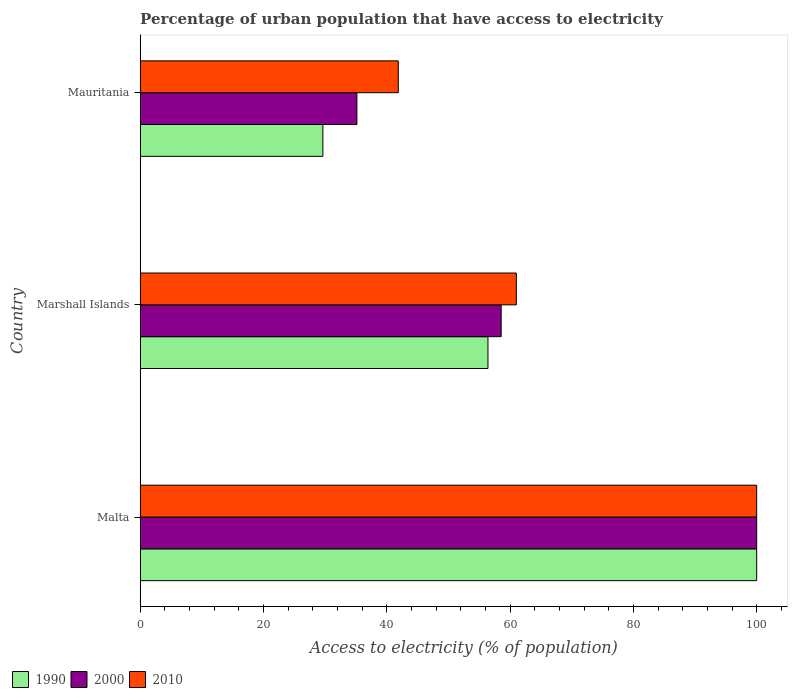How many different coloured bars are there?
Give a very brief answer. 3. Are the number of bars per tick equal to the number of legend labels?
Offer a terse response. Yes. How many bars are there on the 1st tick from the top?
Give a very brief answer. 3. How many bars are there on the 1st tick from the bottom?
Ensure brevity in your answer.  3. What is the label of the 3rd group of bars from the top?
Provide a succinct answer. Malta. In how many cases, is the number of bars for a given country not equal to the number of legend labels?
Your response must be concise. 0. What is the percentage of urban population that have access to electricity in 2000 in Mauritania?
Offer a terse response. 35.15. Across all countries, what is the minimum percentage of urban population that have access to electricity in 2000?
Ensure brevity in your answer.  35.15. In which country was the percentage of urban population that have access to electricity in 1990 maximum?
Offer a terse response. Malta. In which country was the percentage of urban population that have access to electricity in 2010 minimum?
Your response must be concise. Mauritania. What is the total percentage of urban population that have access to electricity in 2000 in the graph?
Provide a short and direct response. 193.7. What is the difference between the percentage of urban population that have access to electricity in 2000 in Marshall Islands and that in Mauritania?
Provide a succinct answer. 23.4. What is the difference between the percentage of urban population that have access to electricity in 2000 in Marshall Islands and the percentage of urban population that have access to electricity in 1990 in Mauritania?
Offer a very short reply. 28.92. What is the average percentage of urban population that have access to electricity in 1990 per country?
Provide a succinct answer. 62.01. What is the difference between the percentage of urban population that have access to electricity in 2000 and percentage of urban population that have access to electricity in 2010 in Malta?
Your answer should be compact. 0. In how many countries, is the percentage of urban population that have access to electricity in 1990 greater than 52 %?
Offer a very short reply. 2. What is the ratio of the percentage of urban population that have access to electricity in 1990 in Malta to that in Marshall Islands?
Offer a terse response. 1.77. What is the difference between the highest and the second highest percentage of urban population that have access to electricity in 2000?
Offer a terse response. 41.45. What is the difference between the highest and the lowest percentage of urban population that have access to electricity in 2000?
Make the answer very short. 64.85. Is the sum of the percentage of urban population that have access to electricity in 2010 in Marshall Islands and Mauritania greater than the maximum percentage of urban population that have access to electricity in 2000 across all countries?
Your answer should be very brief. Yes. What does the 1st bar from the top in Malta represents?
Your answer should be very brief. 2010. Are all the bars in the graph horizontal?
Your answer should be very brief. Yes. How many countries are there in the graph?
Your answer should be very brief. 3. What is the difference between two consecutive major ticks on the X-axis?
Keep it short and to the point. 20. How many legend labels are there?
Ensure brevity in your answer.  3. What is the title of the graph?
Your answer should be compact. Percentage of urban population that have access to electricity. Does "1970" appear as one of the legend labels in the graph?
Your answer should be compact. No. What is the label or title of the X-axis?
Your response must be concise. Access to electricity (% of population). What is the label or title of the Y-axis?
Provide a short and direct response. Country. What is the Access to electricity (% of population) of 1990 in Malta?
Offer a very short reply. 100. What is the Access to electricity (% of population) in 1990 in Marshall Islands?
Provide a succinct answer. 56.41. What is the Access to electricity (% of population) in 2000 in Marshall Islands?
Make the answer very short. 58.55. What is the Access to electricity (% of population) in 2010 in Marshall Islands?
Your response must be concise. 61.01. What is the Access to electricity (% of population) of 1990 in Mauritania?
Your response must be concise. 29.63. What is the Access to electricity (% of population) of 2000 in Mauritania?
Make the answer very short. 35.15. What is the Access to electricity (% of population) of 2010 in Mauritania?
Your response must be concise. 41.86. Across all countries, what is the minimum Access to electricity (% of population) in 1990?
Make the answer very short. 29.63. Across all countries, what is the minimum Access to electricity (% of population) of 2000?
Provide a succinct answer. 35.15. Across all countries, what is the minimum Access to electricity (% of population) in 2010?
Ensure brevity in your answer.  41.86. What is the total Access to electricity (% of population) of 1990 in the graph?
Your answer should be compact. 186.04. What is the total Access to electricity (% of population) of 2000 in the graph?
Provide a short and direct response. 193.7. What is the total Access to electricity (% of population) of 2010 in the graph?
Your response must be concise. 202.88. What is the difference between the Access to electricity (% of population) in 1990 in Malta and that in Marshall Islands?
Your answer should be very brief. 43.59. What is the difference between the Access to electricity (% of population) in 2000 in Malta and that in Marshall Islands?
Ensure brevity in your answer.  41.45. What is the difference between the Access to electricity (% of population) of 2010 in Malta and that in Marshall Islands?
Your answer should be compact. 38.99. What is the difference between the Access to electricity (% of population) of 1990 in Malta and that in Mauritania?
Give a very brief answer. 70.37. What is the difference between the Access to electricity (% of population) of 2000 in Malta and that in Mauritania?
Your response must be concise. 64.85. What is the difference between the Access to electricity (% of population) in 2010 in Malta and that in Mauritania?
Provide a short and direct response. 58.14. What is the difference between the Access to electricity (% of population) in 1990 in Marshall Islands and that in Mauritania?
Provide a short and direct response. 26.78. What is the difference between the Access to electricity (% of population) of 2000 in Marshall Islands and that in Mauritania?
Make the answer very short. 23.4. What is the difference between the Access to electricity (% of population) in 2010 in Marshall Islands and that in Mauritania?
Keep it short and to the point. 19.15. What is the difference between the Access to electricity (% of population) in 1990 in Malta and the Access to electricity (% of population) in 2000 in Marshall Islands?
Offer a very short reply. 41.45. What is the difference between the Access to electricity (% of population) of 1990 in Malta and the Access to electricity (% of population) of 2010 in Marshall Islands?
Keep it short and to the point. 38.99. What is the difference between the Access to electricity (% of population) of 2000 in Malta and the Access to electricity (% of population) of 2010 in Marshall Islands?
Your response must be concise. 38.99. What is the difference between the Access to electricity (% of population) of 1990 in Malta and the Access to electricity (% of population) of 2000 in Mauritania?
Provide a succinct answer. 64.85. What is the difference between the Access to electricity (% of population) of 1990 in Malta and the Access to electricity (% of population) of 2010 in Mauritania?
Your answer should be compact. 58.14. What is the difference between the Access to electricity (% of population) in 2000 in Malta and the Access to electricity (% of population) in 2010 in Mauritania?
Make the answer very short. 58.14. What is the difference between the Access to electricity (% of population) of 1990 in Marshall Islands and the Access to electricity (% of population) of 2000 in Mauritania?
Give a very brief answer. 21.26. What is the difference between the Access to electricity (% of population) of 1990 in Marshall Islands and the Access to electricity (% of population) of 2010 in Mauritania?
Offer a very short reply. 14.55. What is the difference between the Access to electricity (% of population) of 2000 in Marshall Islands and the Access to electricity (% of population) of 2010 in Mauritania?
Your answer should be compact. 16.69. What is the average Access to electricity (% of population) of 1990 per country?
Provide a short and direct response. 62.01. What is the average Access to electricity (% of population) of 2000 per country?
Offer a terse response. 64.57. What is the average Access to electricity (% of population) in 2010 per country?
Your answer should be very brief. 67.63. What is the difference between the Access to electricity (% of population) of 1990 and Access to electricity (% of population) of 2000 in Malta?
Your answer should be compact. 0. What is the difference between the Access to electricity (% of population) of 1990 and Access to electricity (% of population) of 2010 in Malta?
Provide a short and direct response. 0. What is the difference between the Access to electricity (% of population) of 1990 and Access to electricity (% of population) of 2000 in Marshall Islands?
Your answer should be very brief. -2.14. What is the difference between the Access to electricity (% of population) in 1990 and Access to electricity (% of population) in 2010 in Marshall Islands?
Make the answer very short. -4.6. What is the difference between the Access to electricity (% of population) in 2000 and Access to electricity (% of population) in 2010 in Marshall Islands?
Keep it short and to the point. -2.46. What is the difference between the Access to electricity (% of population) in 1990 and Access to electricity (% of population) in 2000 in Mauritania?
Your answer should be very brief. -5.52. What is the difference between the Access to electricity (% of population) of 1990 and Access to electricity (% of population) of 2010 in Mauritania?
Make the answer very short. -12.23. What is the difference between the Access to electricity (% of population) in 2000 and Access to electricity (% of population) in 2010 in Mauritania?
Make the answer very short. -6.71. What is the ratio of the Access to electricity (% of population) in 1990 in Malta to that in Marshall Islands?
Keep it short and to the point. 1.77. What is the ratio of the Access to electricity (% of population) in 2000 in Malta to that in Marshall Islands?
Provide a short and direct response. 1.71. What is the ratio of the Access to electricity (% of population) of 2010 in Malta to that in Marshall Islands?
Offer a terse response. 1.64. What is the ratio of the Access to electricity (% of population) of 1990 in Malta to that in Mauritania?
Make the answer very short. 3.37. What is the ratio of the Access to electricity (% of population) of 2000 in Malta to that in Mauritania?
Provide a short and direct response. 2.85. What is the ratio of the Access to electricity (% of population) of 2010 in Malta to that in Mauritania?
Offer a very short reply. 2.39. What is the ratio of the Access to electricity (% of population) of 1990 in Marshall Islands to that in Mauritania?
Provide a short and direct response. 1.9. What is the ratio of the Access to electricity (% of population) of 2000 in Marshall Islands to that in Mauritania?
Provide a short and direct response. 1.67. What is the ratio of the Access to electricity (% of population) in 2010 in Marshall Islands to that in Mauritania?
Give a very brief answer. 1.46. What is the difference between the highest and the second highest Access to electricity (% of population) of 1990?
Give a very brief answer. 43.59. What is the difference between the highest and the second highest Access to electricity (% of population) in 2000?
Make the answer very short. 41.45. What is the difference between the highest and the second highest Access to electricity (% of population) of 2010?
Offer a terse response. 38.99. What is the difference between the highest and the lowest Access to electricity (% of population) in 1990?
Your answer should be very brief. 70.37. What is the difference between the highest and the lowest Access to electricity (% of population) of 2000?
Make the answer very short. 64.85. What is the difference between the highest and the lowest Access to electricity (% of population) in 2010?
Your answer should be very brief. 58.14. 